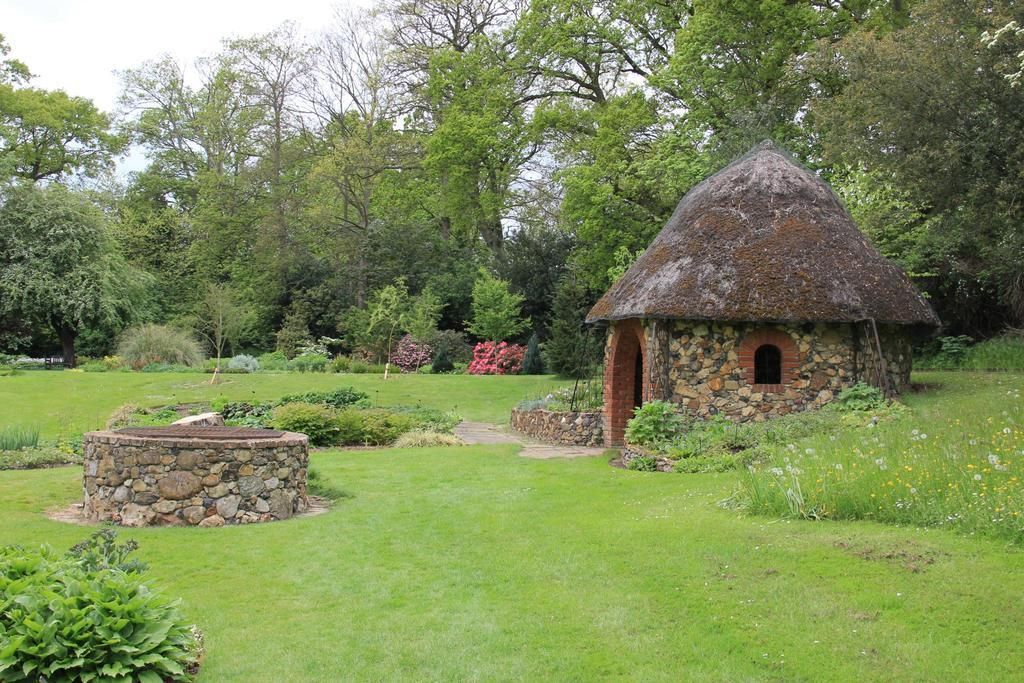What type of vegetation can be seen in the image? There are trees, grass, and plants in the image. What type of structure is present in the image? There is a house in the image. What object can be seen on the left side of the image? There is a stone object on the left side of the image. What is visible in the background of the image? The sky is visible in the background of the image. How many rings are visible on the tree in the image? There are no rings visible on any trees in the image, as the image does not show tree rings. 